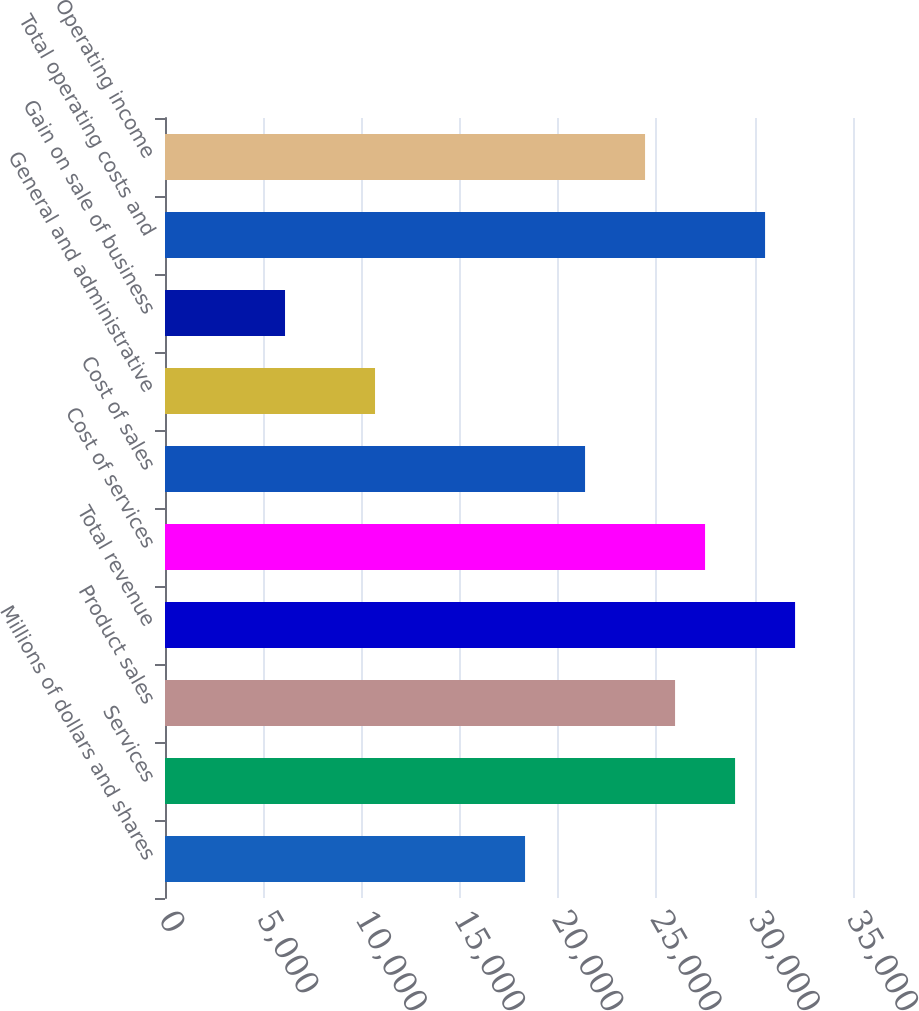<chart> <loc_0><loc_0><loc_500><loc_500><bar_chart><fcel>Millions of dollars and shares<fcel>Services<fcel>Product sales<fcel>Total revenue<fcel>Cost of services<fcel>Cost of sales<fcel>General and administrative<fcel>Gain on sale of business<fcel>Total operating costs and<fcel>Operating income<nl><fcel>18316.5<fcel>29000.6<fcel>25948<fcel>32053.2<fcel>27474.3<fcel>21369.1<fcel>10685.1<fcel>6106.23<fcel>30526.9<fcel>24421.7<nl></chart> 